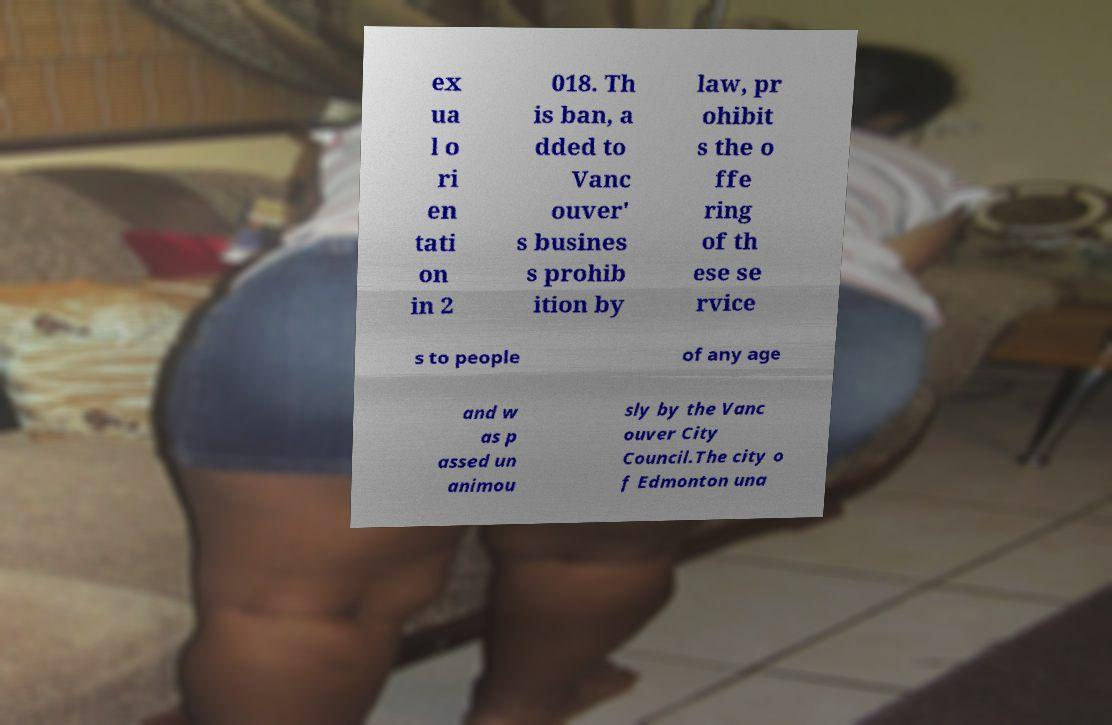Could you extract and type out the text from this image? ex ua l o ri en tati on in 2 018. Th is ban, a dded to Vanc ouver' s busines s prohib ition by law, pr ohibit s the o ffe ring of th ese se rvice s to people of any age and w as p assed un animou sly by the Vanc ouver City Council.The city o f Edmonton una 